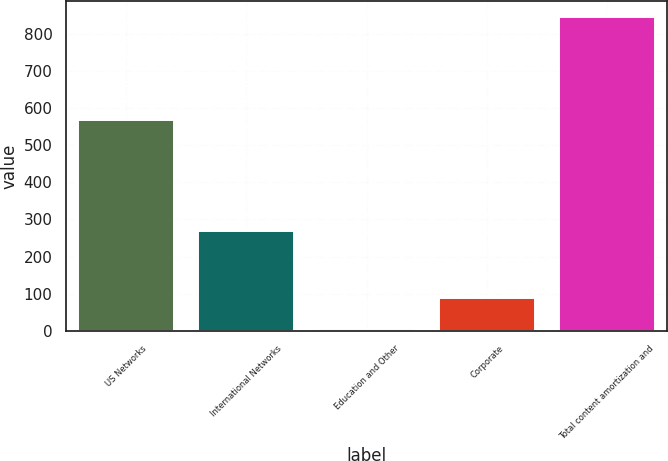Convert chart. <chart><loc_0><loc_0><loc_500><loc_500><bar_chart><fcel>US Networks<fcel>International Networks<fcel>Education and Other<fcel>Corporate<fcel>Total content amortization and<nl><fcel>567<fcel>270<fcel>4<fcel>88.2<fcel>846<nl></chart> 